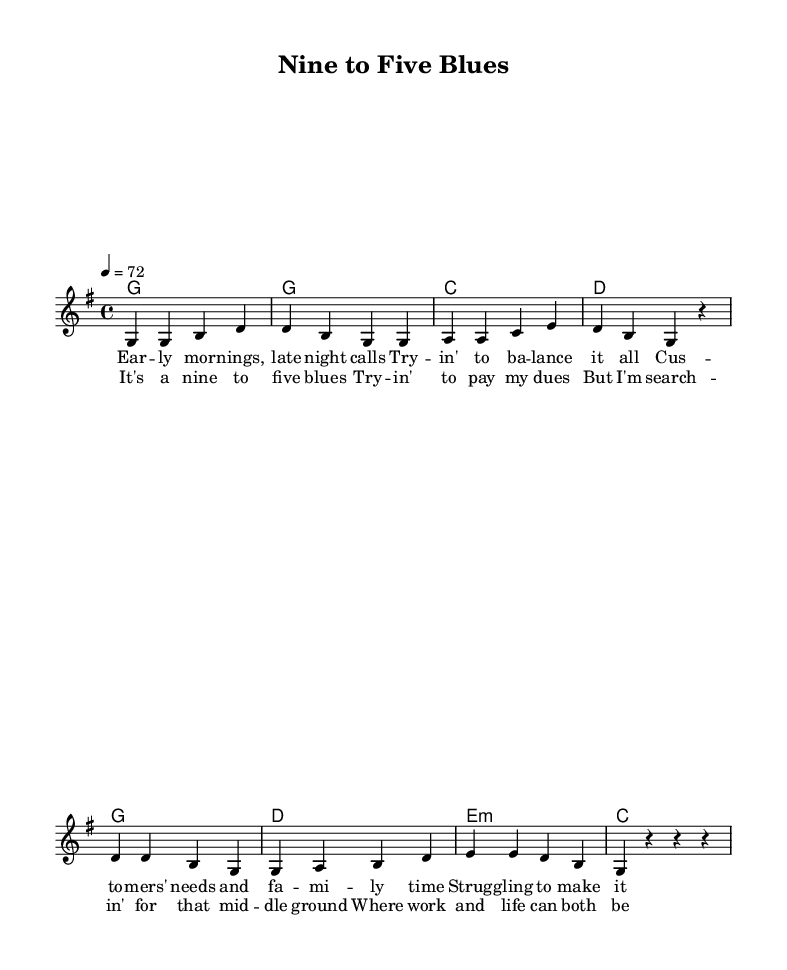What is the key signature of this music? The key signature indicated in the music is G major, which has one sharp (F#). This can be determined by the key signature marking at the beginning of the score.
Answer: G major What is the time signature of this music? The time signature specified is 4/4, which shows that there are four beats in each measure and a quarter note gets one beat, as indicated near the beginning of the score.
Answer: 4/4 What is the tempo marking of this music? The tempo marking is indicated as 4 = 72, meaning that there are 72 beats per minute, with the quarter note receiving one beat. This is shown at the start of the score with the tempo notation.
Answer: 72 How many measures are in the verse? The verse consists of four measures which can be counted as there are four groups of notes ending with a bar line in the section labeled as the verse.
Answer: Four What type of chord precedes the chorus? The chord preceding the chorus is G major, as seen in the chord section before the chorus lyrics begin, marking the transition between sections.
Answer: G What is the theme of the lyrics in this ballad? The lyrics of the ballad explore the struggle of balancing work responsibilities and family time, reflecting on the challenges of modern life. This theme is identified through phrases in the verse that mention "balancing" and "struggling."
Answer: Work-life balance What is the title of this piece? The title of the piece is "Nine to Five Blues," which appears in the header section of the score, identifying the song.
Answer: Nine to Five Blues 